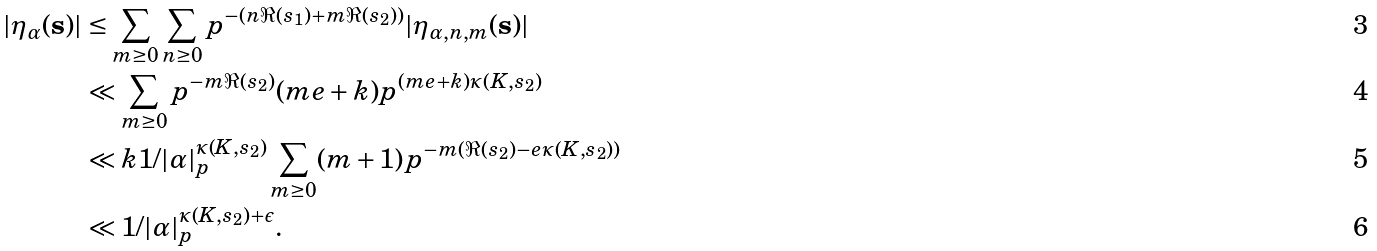<formula> <loc_0><loc_0><loc_500><loc_500>| \eta _ { \alpha } ( \mathbf s ) | & \leq \sum _ { m \geq 0 } \sum _ { n \geq 0 } p ^ { - ( n \Re ( s _ { 1 } ) + m \Re ( s _ { 2 } ) ) } | \eta _ { \alpha , n , m } ( \mathbf s ) | \\ & \ll \sum _ { m \geq 0 } p ^ { - m \Re ( s _ { 2 } ) } ( m e + k ) p ^ { ( m e + k ) \kappa ( K , s _ { 2 } ) } \\ & \ll k 1 / | \alpha | _ { p } ^ { \kappa ( K , s _ { 2 } ) } \sum _ { m \geq 0 } ( m + 1 ) p ^ { - m ( \Re ( s _ { 2 } ) - e \kappa ( K , s _ { 2 } ) ) } \\ & \ll 1 / | \alpha | _ { p } ^ { \kappa ( K , s _ { 2 } ) + \epsilon } .</formula> 